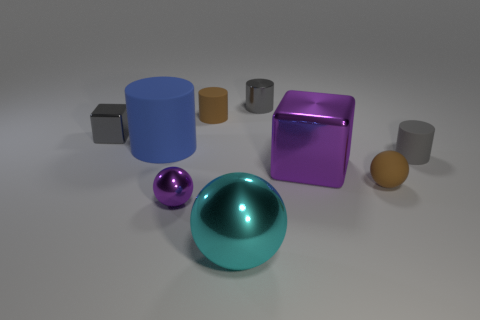There is a metallic ball that is the same size as the gray shiny block; what is its color?
Offer a terse response. Purple. How many things are either gray objects left of the gray matte thing or shiny things in front of the gray matte object?
Offer a very short reply. 5. How many objects are either small blue metal cubes or cyan objects?
Your response must be concise. 1. There is a shiny thing that is both to the right of the large cyan metallic object and in front of the big blue object; what size is it?
Your response must be concise. Large. How many gray cylinders have the same material as the large blue cylinder?
Your response must be concise. 1. What color is the large ball that is the same material as the gray block?
Make the answer very short. Cyan. There is a small rubber thing behind the big matte object; is it the same color as the rubber sphere?
Offer a very short reply. Yes. There is a gray cylinder in front of the big blue object; what is it made of?
Give a very brief answer. Rubber. Are there the same number of large cyan metallic objects behind the small purple metallic object and tiny purple shiny balls?
Your response must be concise. No. What number of large blocks have the same color as the small metallic block?
Your answer should be compact. 0. 